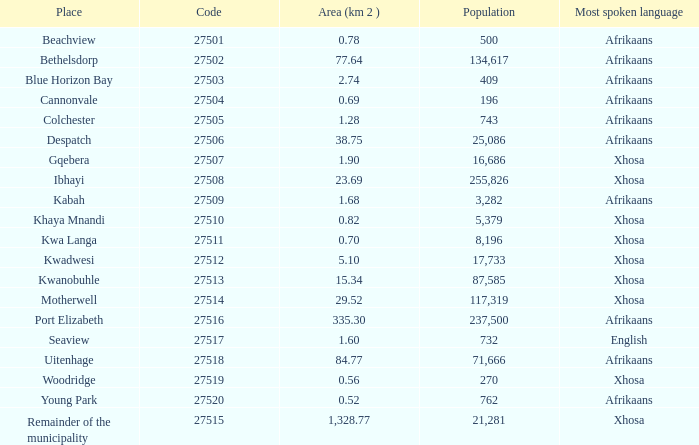What is the total code number for places with a population greater than 87,585? 4.0. 